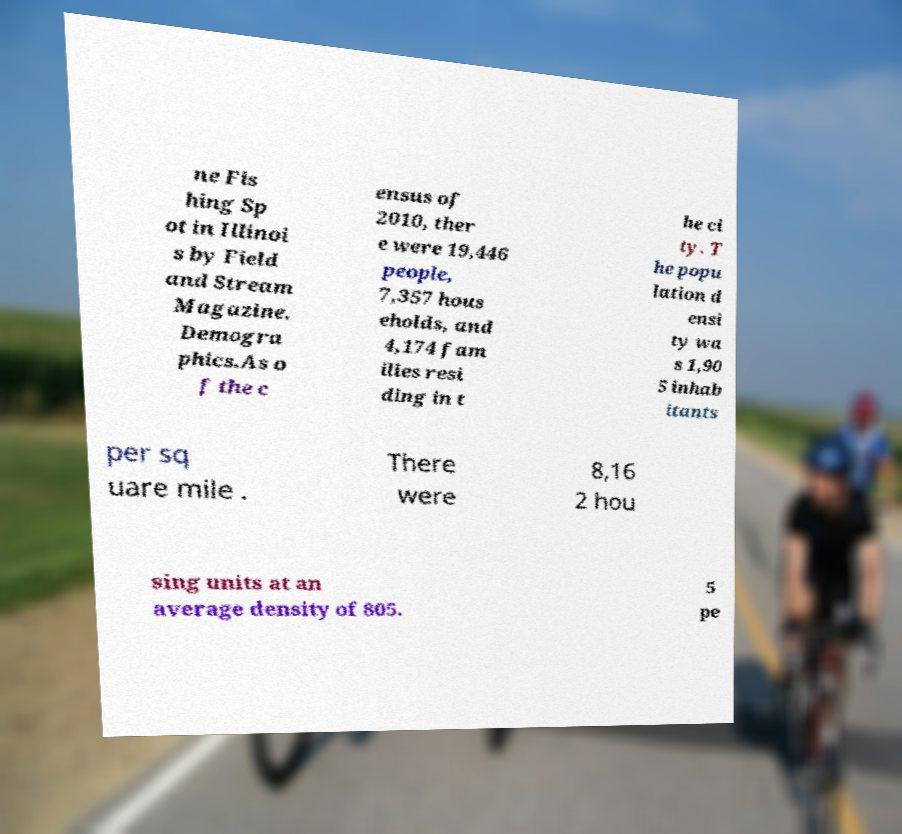For documentation purposes, I need the text within this image transcribed. Could you provide that? ne Fis hing Sp ot in Illinoi s by Field and Stream Magazine. Demogra phics.As o f the c ensus of 2010, ther e were 19,446 people, 7,357 hous eholds, and 4,174 fam ilies resi ding in t he ci ty. T he popu lation d ensi ty wa s 1,90 5 inhab itants per sq uare mile . There were 8,16 2 hou sing units at an average density of 805. 5 pe 